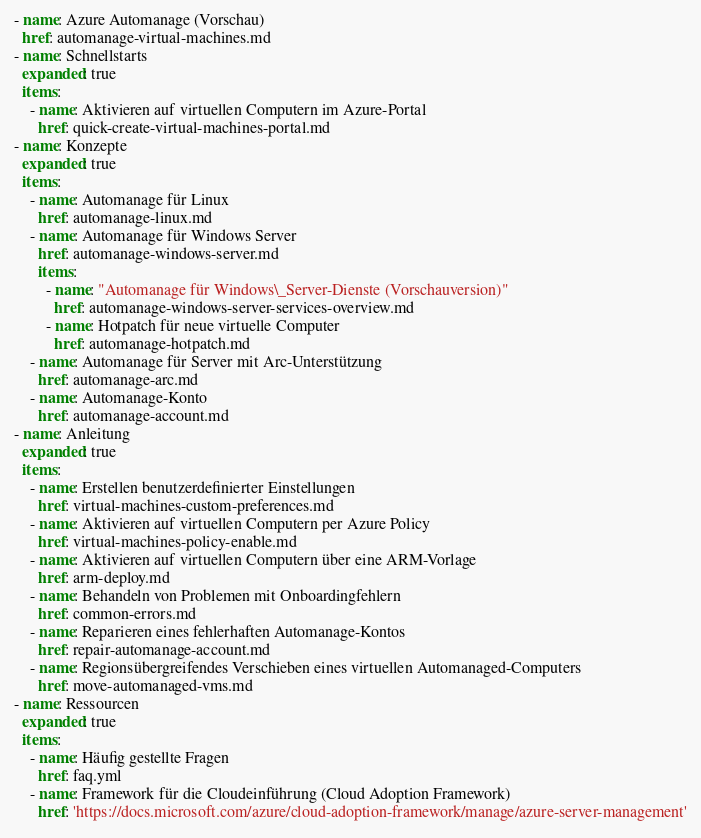Convert code to text. <code><loc_0><loc_0><loc_500><loc_500><_YAML_>- name: Azure Automanage (Vorschau)
  href: automanage-virtual-machines.md
- name: Schnellstarts
  expanded: true
  items:
    - name: Aktivieren auf virtuellen Computern im Azure-Portal
      href: quick-create-virtual-machines-portal.md
- name: Konzepte
  expanded: true
  items:
    - name: Automanage für Linux
      href: automanage-linux.md
    - name: Automanage für Windows Server
      href: automanage-windows-server.md
      items:
        - name: "Automanage für Windows\_Server-Dienste (Vorschauversion)"
          href: automanage-windows-server-services-overview.md
        - name: Hotpatch für neue virtuelle Computer
          href: automanage-hotpatch.md
    - name: Automanage für Server mit Arc-Unterstützung
      href: automanage-arc.md
    - name: Automanage-Konto
      href: automanage-account.md
- name: Anleitung
  expanded: true
  items:
    - name: Erstellen benutzerdefinierter Einstellungen
      href: virtual-machines-custom-preferences.md
    - name: Aktivieren auf virtuellen Computern per Azure Policy
      href: virtual-machines-policy-enable.md
    - name: Aktivieren auf virtuellen Computern über eine ARM-Vorlage
      href: arm-deploy.md
    - name: Behandeln von Problemen mit Onboardingfehlern
      href: common-errors.md
    - name: Reparieren eines fehlerhaften Automanage-Kontos
      href: repair-automanage-account.md
    - name: Regionsübergreifendes Verschieben eines virtuellen Automanaged-Computers
      href: move-automanaged-vms.md
- name: Ressourcen
  expanded: true
  items:
    - name: Häufig gestellte Fragen
      href: faq.yml
    - name: Framework für die Cloudeinführung (Cloud Adoption Framework)
      href: 'https://docs.microsoft.com/azure/cloud-adoption-framework/manage/azure-server-management'</code> 